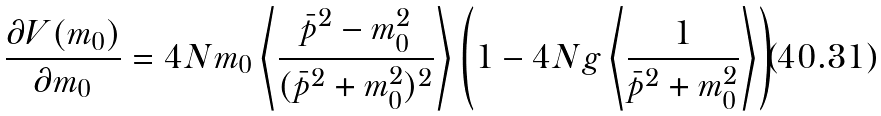<formula> <loc_0><loc_0><loc_500><loc_500>\frac { \partial V ( m _ { 0 } ) } { \partial m _ { 0 } } = 4 N m _ { 0 } \left \langle \frac { \bar { p } ^ { 2 } - m _ { 0 } ^ { 2 } } { ( \bar { p } ^ { 2 } + m _ { 0 } ^ { 2 } ) ^ { 2 } } \right \rangle \left ( 1 - 4 N g \left \langle \frac { 1 } { \bar { p } ^ { 2 } + m _ { 0 } ^ { 2 } } \right \rangle \right )</formula> 